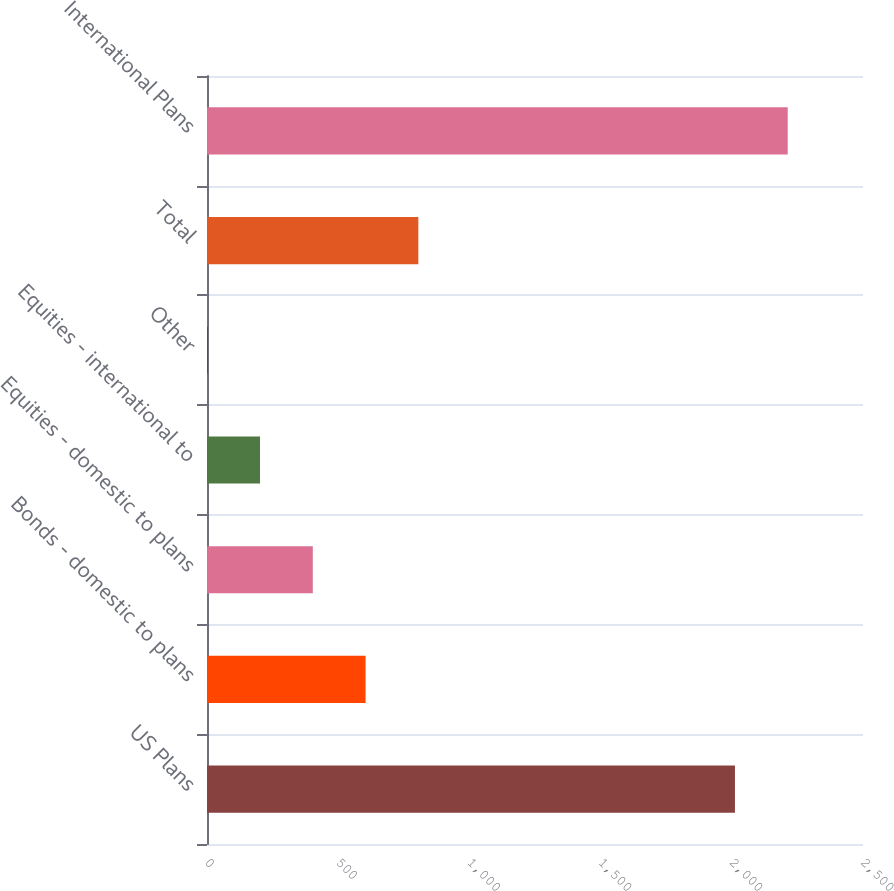Convert chart to OTSL. <chart><loc_0><loc_0><loc_500><loc_500><bar_chart><fcel>US Plans<fcel>Bonds - domestic to plans<fcel>Equities - domestic to plans<fcel>Equities - international to<fcel>Other<fcel>Total<fcel>International Plans<nl><fcel>2012<fcel>604.3<fcel>403.2<fcel>202.1<fcel>1<fcel>805.4<fcel>2213.1<nl></chart> 